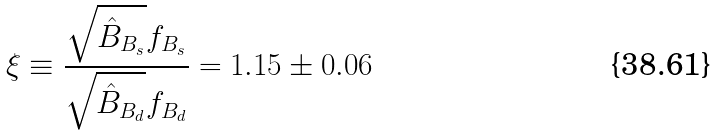<formula> <loc_0><loc_0><loc_500><loc_500>\xi \equiv \frac { \sqrt { \hat { B } _ { B _ { s } } } f _ { B _ { s } } } { \sqrt { \hat { B } _ { B _ { d } } } f _ { B _ { d } } } = 1 . 1 5 \pm 0 . 0 6</formula> 